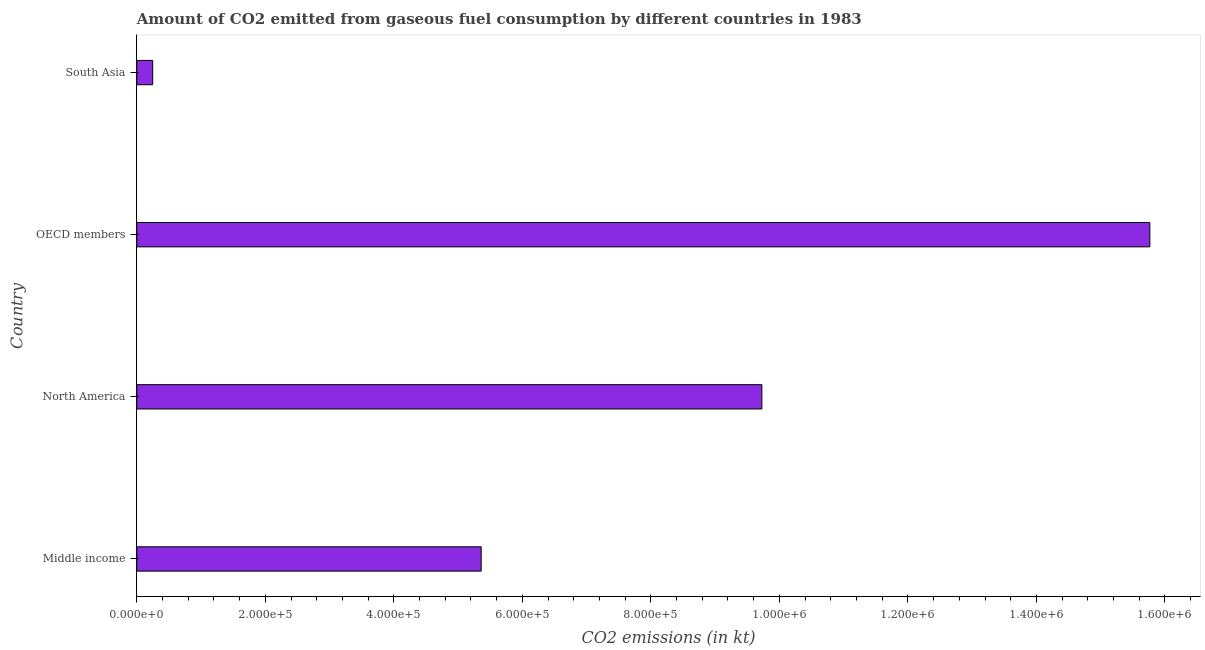Does the graph contain grids?
Provide a short and direct response. No. What is the title of the graph?
Provide a succinct answer. Amount of CO2 emitted from gaseous fuel consumption by different countries in 1983. What is the label or title of the X-axis?
Make the answer very short. CO2 emissions (in kt). What is the co2 emissions from gaseous fuel consumption in OECD members?
Provide a succinct answer. 1.58e+06. Across all countries, what is the maximum co2 emissions from gaseous fuel consumption?
Your answer should be compact. 1.58e+06. Across all countries, what is the minimum co2 emissions from gaseous fuel consumption?
Your response must be concise. 2.48e+04. What is the sum of the co2 emissions from gaseous fuel consumption?
Offer a terse response. 3.11e+06. What is the difference between the co2 emissions from gaseous fuel consumption in Middle income and North America?
Give a very brief answer. -4.37e+05. What is the average co2 emissions from gaseous fuel consumption per country?
Your answer should be very brief. 7.77e+05. What is the median co2 emissions from gaseous fuel consumption?
Keep it short and to the point. 7.54e+05. What is the ratio of the co2 emissions from gaseous fuel consumption in Middle income to that in OECD members?
Your answer should be very brief. 0.34. What is the difference between the highest and the second highest co2 emissions from gaseous fuel consumption?
Make the answer very short. 6.04e+05. Is the sum of the co2 emissions from gaseous fuel consumption in North America and South Asia greater than the maximum co2 emissions from gaseous fuel consumption across all countries?
Offer a very short reply. No. What is the difference between the highest and the lowest co2 emissions from gaseous fuel consumption?
Ensure brevity in your answer.  1.55e+06. How many bars are there?
Your answer should be very brief. 4. Are all the bars in the graph horizontal?
Give a very brief answer. Yes. How many countries are there in the graph?
Offer a very short reply. 4. What is the CO2 emissions (in kt) in Middle income?
Provide a succinct answer. 5.36e+05. What is the CO2 emissions (in kt) in North America?
Make the answer very short. 9.73e+05. What is the CO2 emissions (in kt) in OECD members?
Keep it short and to the point. 1.58e+06. What is the CO2 emissions (in kt) of South Asia?
Give a very brief answer. 2.48e+04. What is the difference between the CO2 emissions (in kt) in Middle income and North America?
Offer a very short reply. -4.37e+05. What is the difference between the CO2 emissions (in kt) in Middle income and OECD members?
Keep it short and to the point. -1.04e+06. What is the difference between the CO2 emissions (in kt) in Middle income and South Asia?
Offer a terse response. 5.11e+05. What is the difference between the CO2 emissions (in kt) in North America and OECD members?
Ensure brevity in your answer.  -6.04e+05. What is the difference between the CO2 emissions (in kt) in North America and South Asia?
Your response must be concise. 9.48e+05. What is the difference between the CO2 emissions (in kt) in OECD members and South Asia?
Offer a very short reply. 1.55e+06. What is the ratio of the CO2 emissions (in kt) in Middle income to that in North America?
Your response must be concise. 0.55. What is the ratio of the CO2 emissions (in kt) in Middle income to that in OECD members?
Ensure brevity in your answer.  0.34. What is the ratio of the CO2 emissions (in kt) in Middle income to that in South Asia?
Your answer should be compact. 21.64. What is the ratio of the CO2 emissions (in kt) in North America to that in OECD members?
Give a very brief answer. 0.62. What is the ratio of the CO2 emissions (in kt) in North America to that in South Asia?
Provide a short and direct response. 39.28. What is the ratio of the CO2 emissions (in kt) in OECD members to that in South Asia?
Your response must be concise. 63.66. 